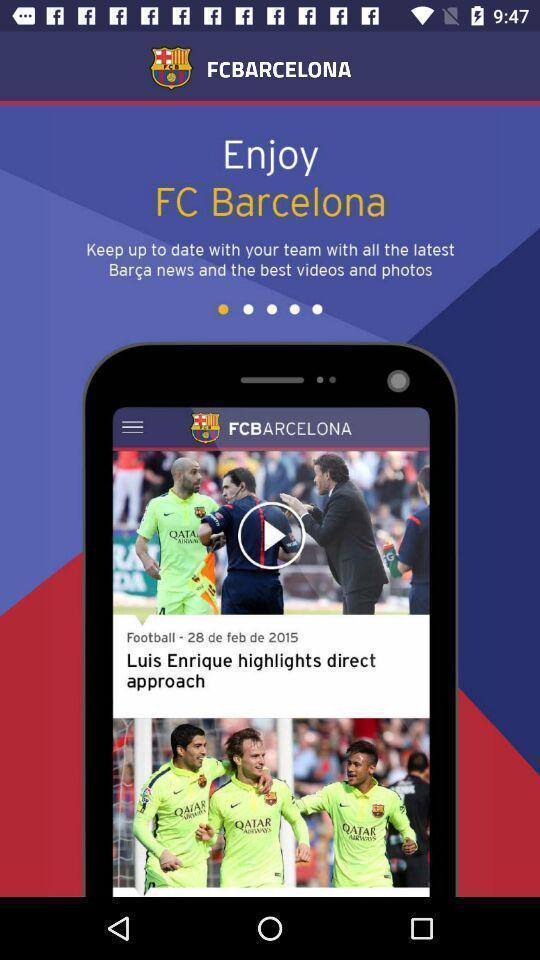What is the overall content of this screenshot? Screen showing page of an news application. 